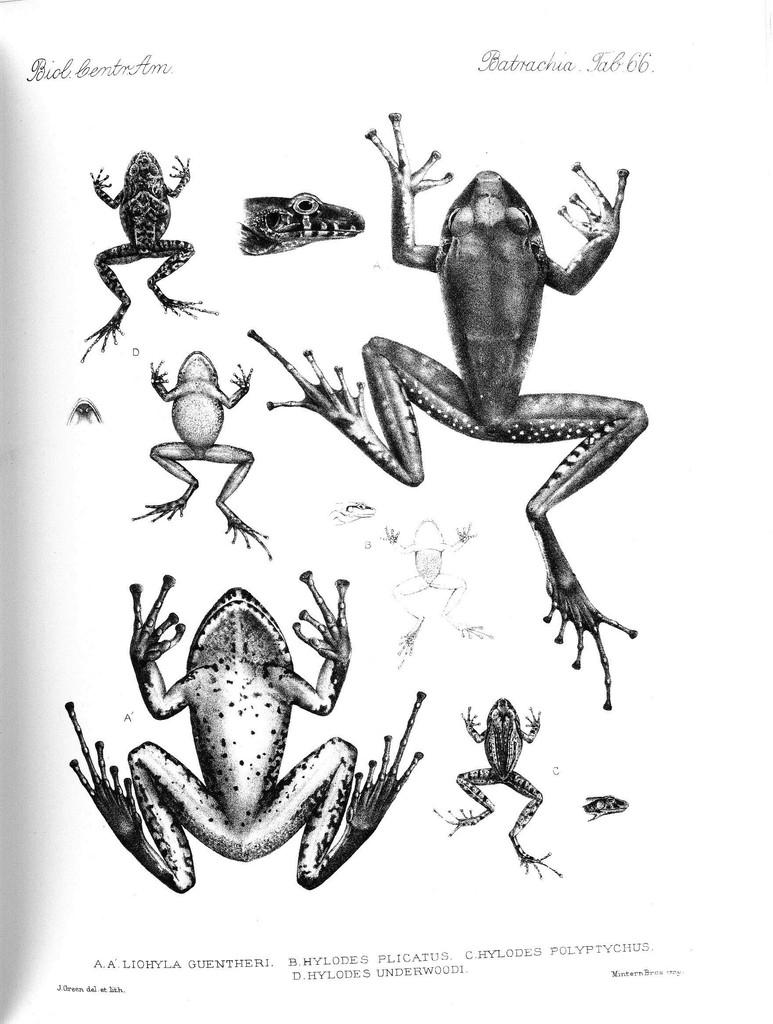What is the main subject of the image? There is a picture in the image. What is depicted in the picture? The picture contains frogs. What type of toy can be seen in the image? There is no toy present in the image; it contains a picture of frogs. Are there any dogs visible in the image? There are no dogs depicted in the image; it features a picture of frogs. 